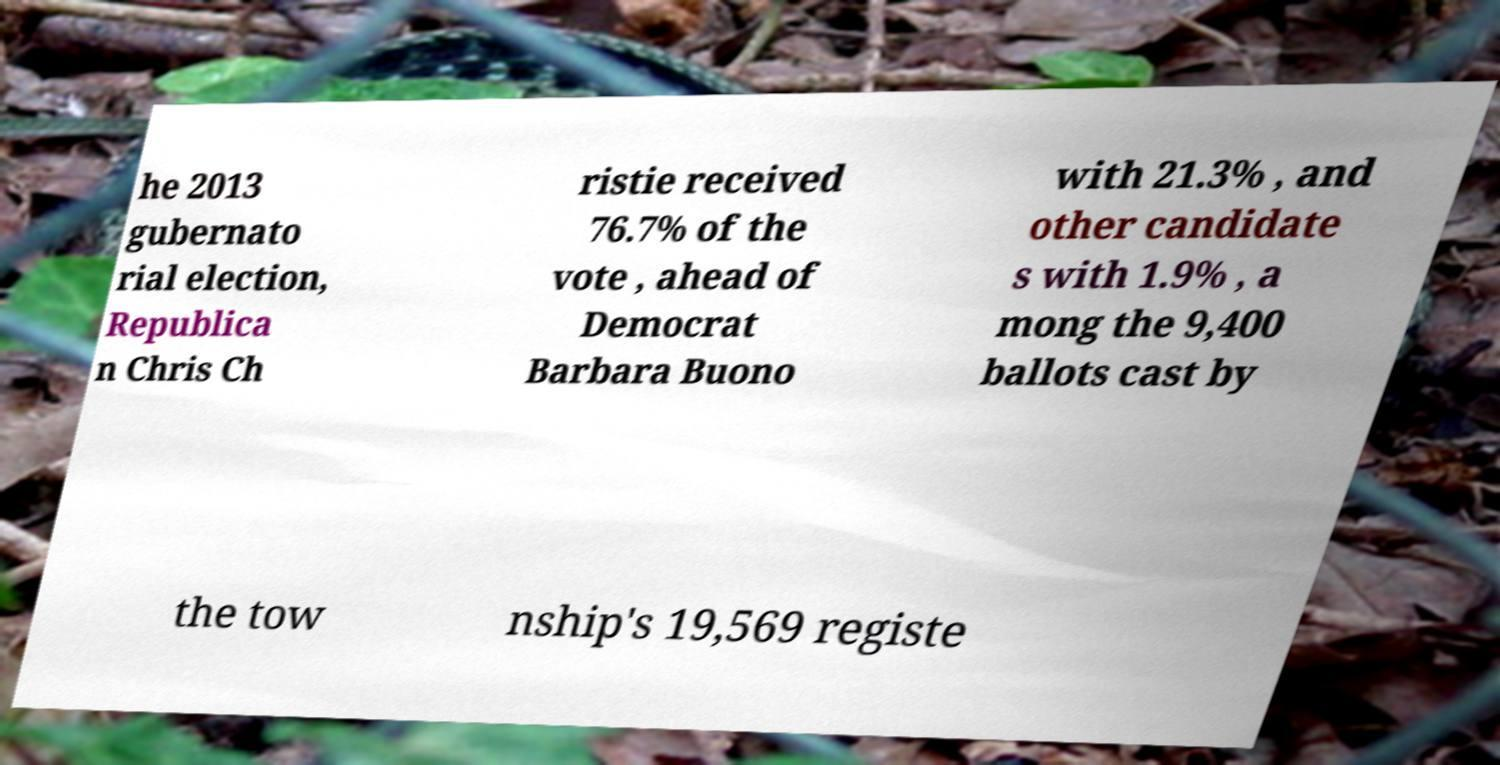Please read and relay the text visible in this image. What does it say? he 2013 gubernato rial election, Republica n Chris Ch ristie received 76.7% of the vote , ahead of Democrat Barbara Buono with 21.3% , and other candidate s with 1.9% , a mong the 9,400 ballots cast by the tow nship's 19,569 registe 